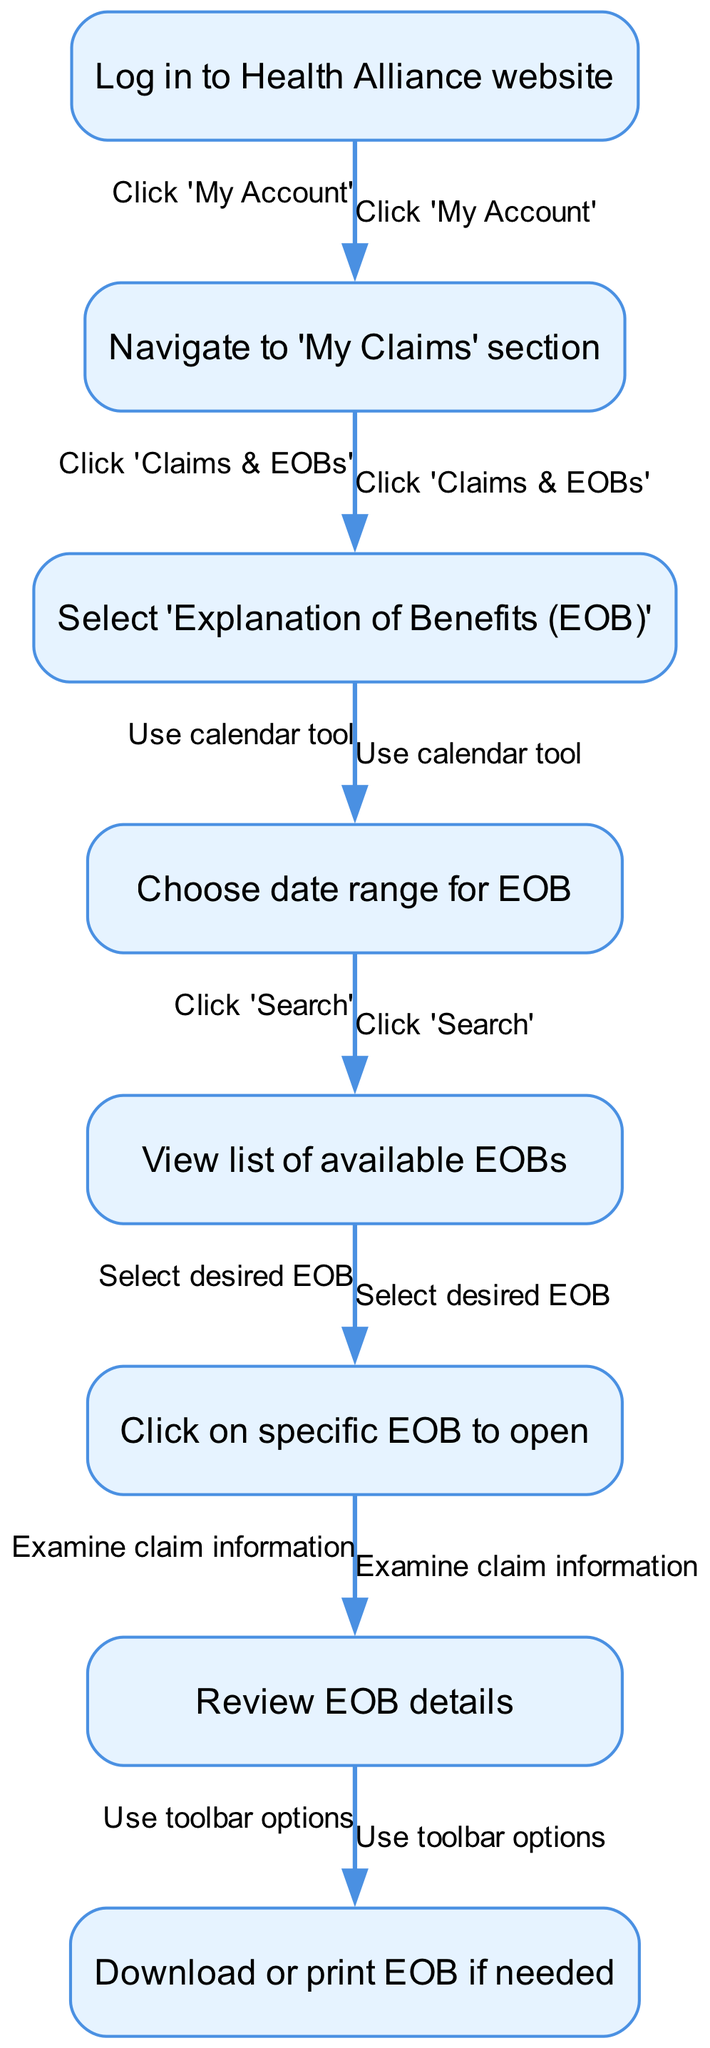What is the first step to access my Explanation of Benefits? The first step in the flow of the diagram is to log in to the Health Alliance website, as shown in the starting node.
Answer: Log in to Health Alliance website How many major steps are there in the process to view an EOB? Counting the steps starting from logging in to downloading or printing the EOB, there are a total of seven major steps represented by the nodes in the diagram.
Answer: Seven What section do you need to navigate to after logging in? After logging in, the next step is to navigate to the 'My Claims' section, as shown in the process flow.
Answer: My Claims section What do you click after selecting 'Explanation of Benefits'? After selecting 'Explanation of Benefits', you need to use the calendar tool to choose the date range for the EOB, which is indicated as the next step in the flow.
Answer: Use calendar tool What happens after reviewing EOB details? After reviewing the details of the EOB, the final step in the flow allows for options to download or print the EOB if needed, completing the process.
Answer: Download or print EOB Which step involves selecting a specific EOB? Selecting a specific EOB occurs after viewing the list of available EOBs, as indicated by the flow from step four to step five.
Answer: Click on specific EOB to open What is the last action you can take after examining the EOB details? The last action you can take is to use the toolbar options for downloading or printing the EOB, which is shown in the last step of the diagram.
Answer: Use toolbar options 